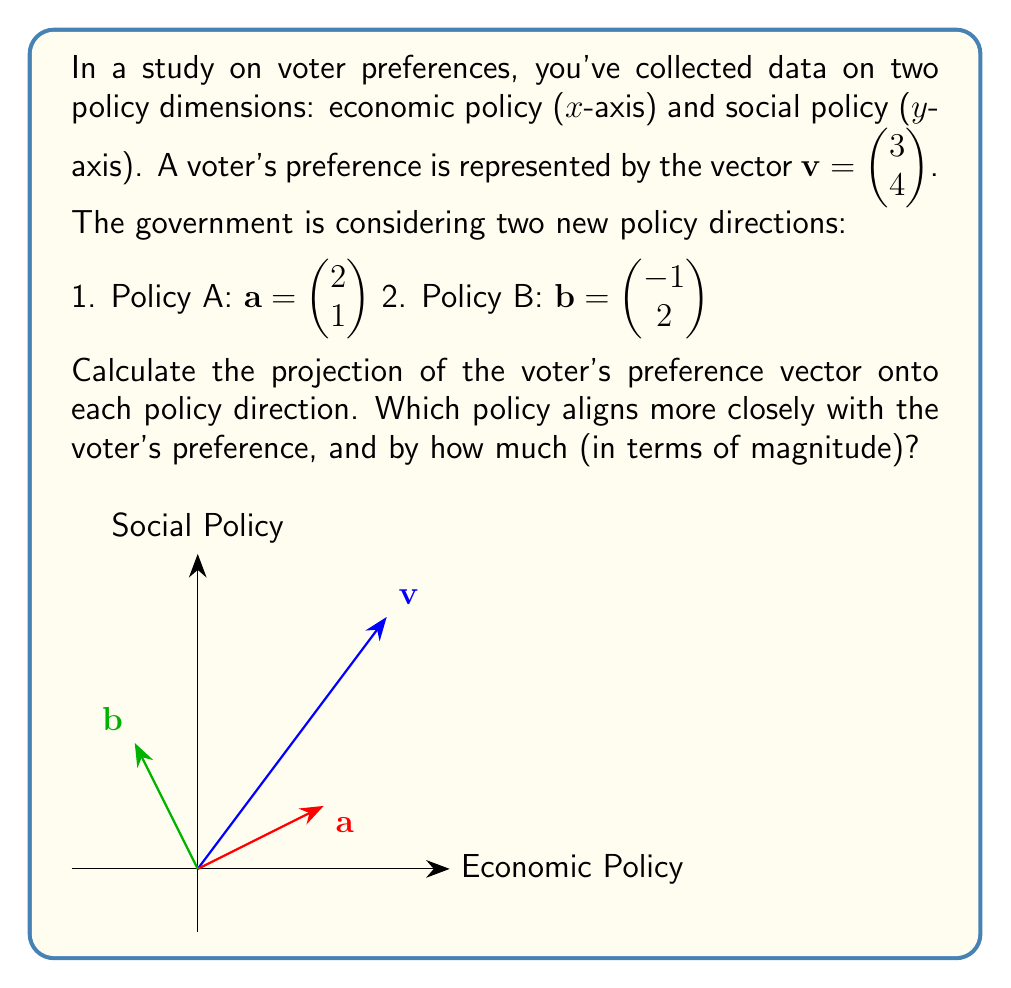Provide a solution to this math problem. Let's approach this step-by-step:

1) First, we need to calculate the projections of $\mathbf{v}$ onto $\mathbf{a}$ and $\mathbf{b}$. The formula for vector projection is:

   $$\text{proj}_{\mathbf{u}}\mathbf{v} = \frac{\mathbf{v} \cdot \mathbf{u}}{\|\mathbf{u}\|^2} \mathbf{u}$$

2) For Policy A:
   $\mathbf{v} \cdot \mathbf{a} = 3(2) + 4(1) = 10$
   $\|\mathbf{a}\|^2 = 2^2 + 1^2 = 5$
   
   $$\text{proj}_{\mathbf{a}}\mathbf{v} = \frac{10}{5} \begin{pmatrix} 2 \\ 1 \end{pmatrix} = \begin{pmatrix} 4 \\ 2 \end{pmatrix}$$

3) For Policy B:
   $\mathbf{v} \cdot \mathbf{b} = 3(-1) + 4(2) = 5$
   $\|\mathbf{b}\|^2 = (-1)^2 + 2^2 = 5$
   
   $$\text{proj}_{\mathbf{b}}\mathbf{v} = \frac{5}{5} \begin{pmatrix} -1 \\ 2 \end{pmatrix} = \begin{pmatrix} -1 \\ 2 \end{pmatrix}$$

4) To determine which policy aligns more closely, we need to calculate the magnitudes of these projections:

   $\|\text{proj}_{\mathbf{a}}\mathbf{v}\| = \sqrt{4^2 + 2^2} = \sqrt{20} \approx 4.47$
   $\|\text{proj}_{\mathbf{b}}\mathbf{v}\| = \sqrt{(-1)^2 + 2^2} = \sqrt{5} \approx 2.24$

5) Policy A has a larger projection magnitude, indicating it aligns more closely with the voter's preference.

6) The difference in magnitude is:
   $4.47 - 2.24 = 2.23$

Therefore, Policy A aligns more closely with the voter's preference by a magnitude of approximately 2.23 units.
Answer: Policy A aligns more closely, by approximately 2.23 units. 